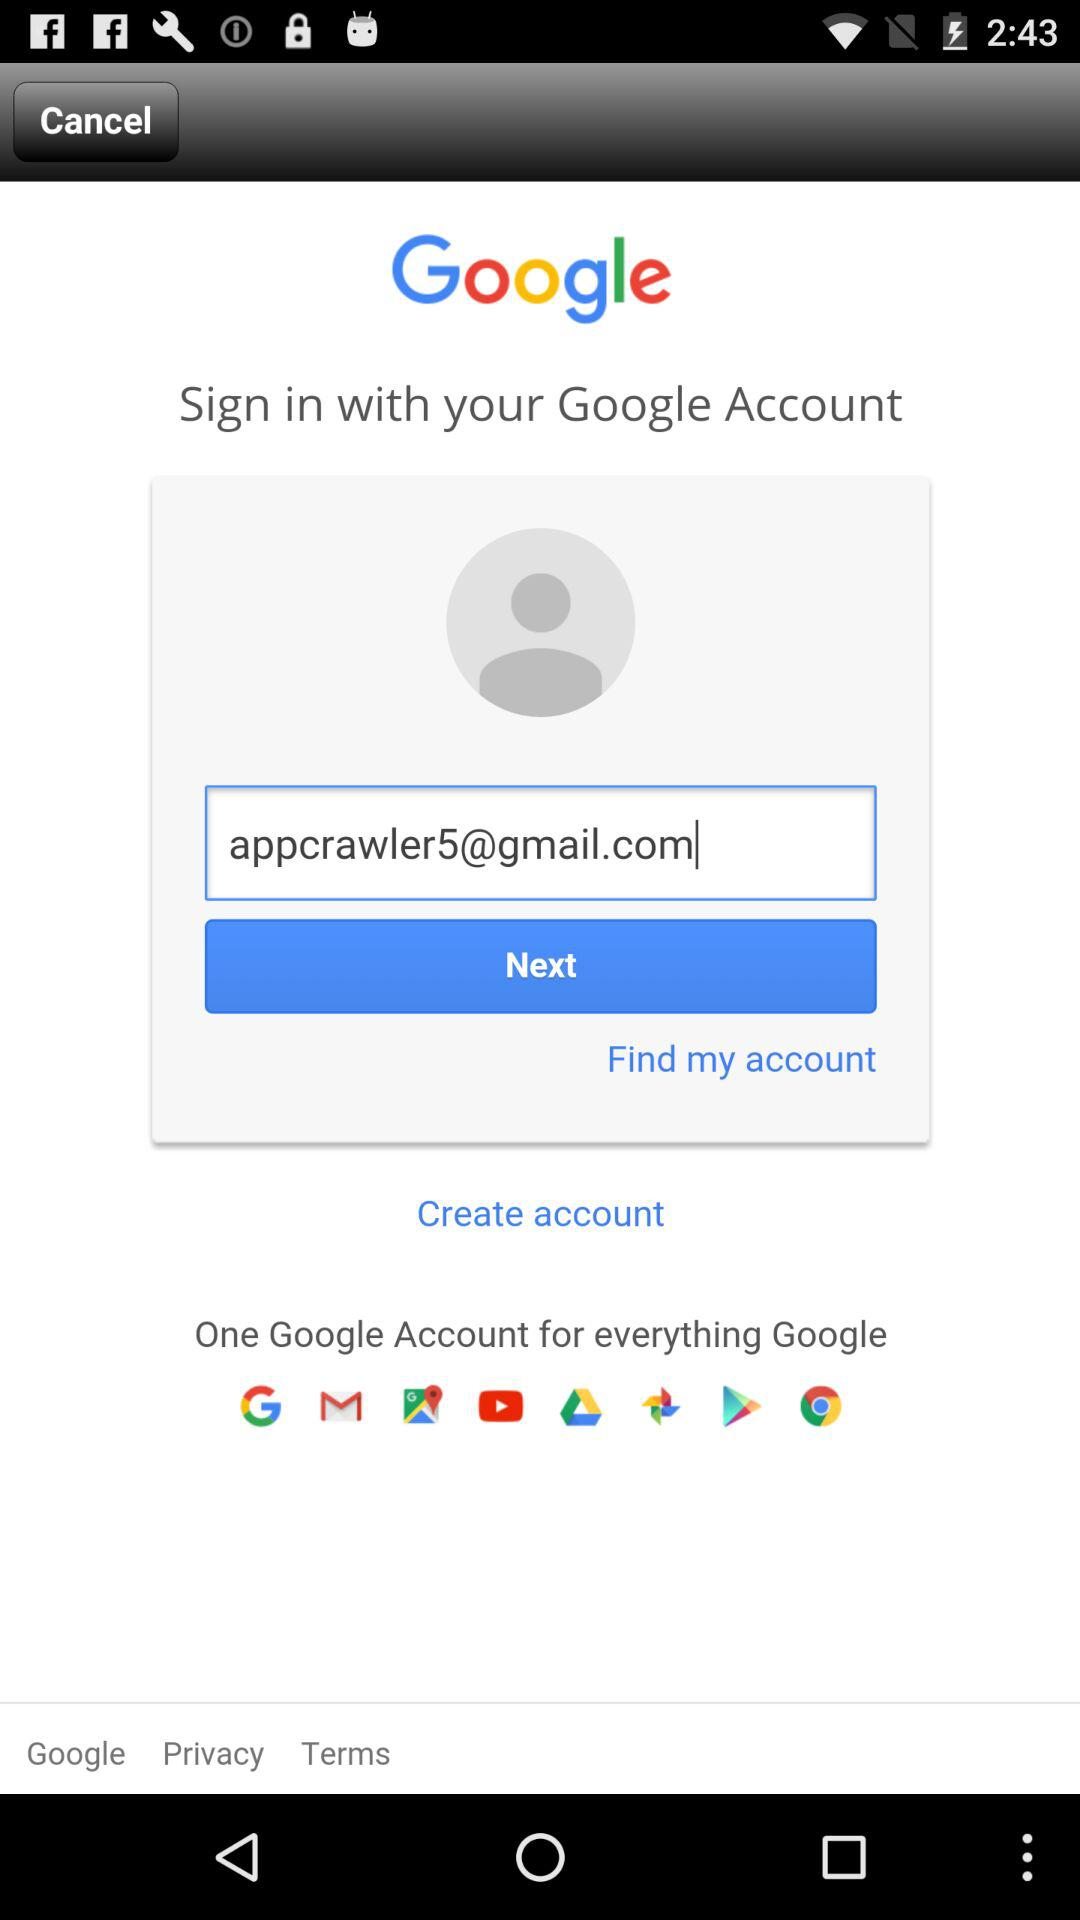How can we sign in? You can sign in with a "Google Account". 